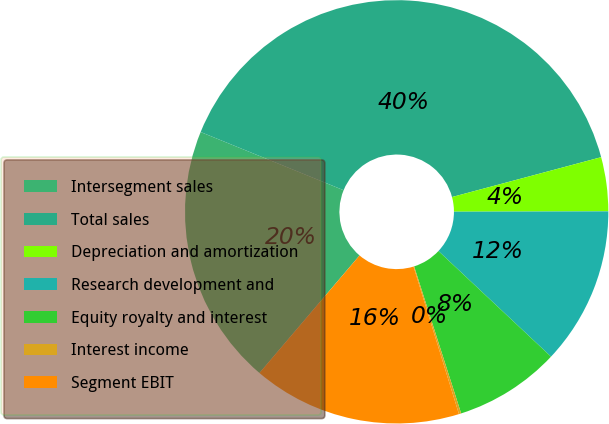Convert chart. <chart><loc_0><loc_0><loc_500><loc_500><pie_chart><fcel>Intersegment sales<fcel>Total sales<fcel>Depreciation and amortization<fcel>Research development and<fcel>Equity royalty and interest<fcel>Interest income<fcel>Segment EBIT<nl><fcel>19.93%<fcel>39.69%<fcel>4.12%<fcel>12.03%<fcel>8.08%<fcel>0.17%<fcel>15.98%<nl></chart> 